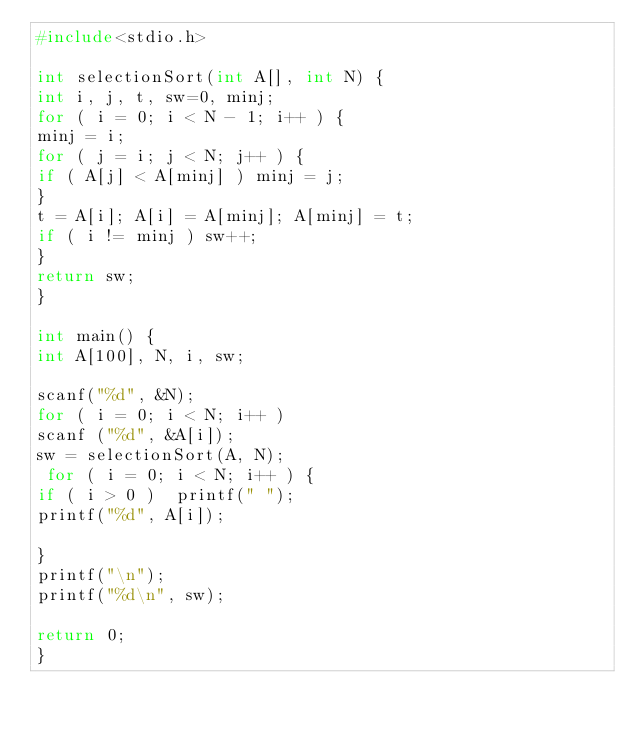<code> <loc_0><loc_0><loc_500><loc_500><_C_>#include<stdio.h>

int selectionSort(int A[], int N) {
int i, j, t, sw=0, minj;
for ( i = 0; i < N - 1; i++ ) {
minj = i;
for ( j = i; j < N; j++ ) {
if ( A[j] < A[minj] ) minj = j;
}
t = A[i]; A[i] = A[minj]; A[minj] = t;
if ( i != minj ) sw++;
}
return sw;
}

int main() {
int A[100], N, i, sw;

scanf("%d", &N);
for ( i = 0; i < N; i++ )
scanf ("%d", &A[i]);
sw = selectionSort(A, N);
 for ( i = 0; i < N; i++ ) {
if ( i > 0 )  printf(" ");
printf("%d", A[i]);

}
printf("\n");
printf("%d\n", sw);

return 0;
}
</code> 